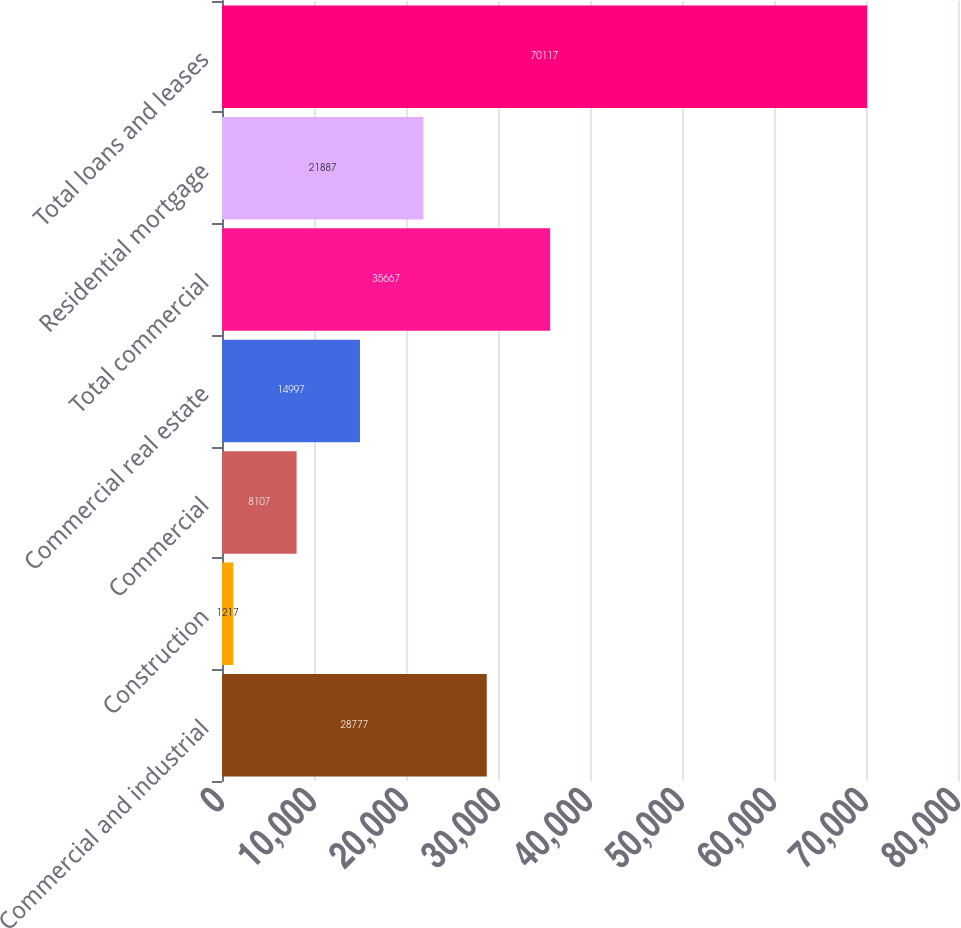Convert chart to OTSL. <chart><loc_0><loc_0><loc_500><loc_500><bar_chart><fcel>Commercial and industrial<fcel>Construction<fcel>Commercial<fcel>Commercial real estate<fcel>Total commercial<fcel>Residential mortgage<fcel>Total loans and leases<nl><fcel>28777<fcel>1217<fcel>8107<fcel>14997<fcel>35667<fcel>21887<fcel>70117<nl></chart> 